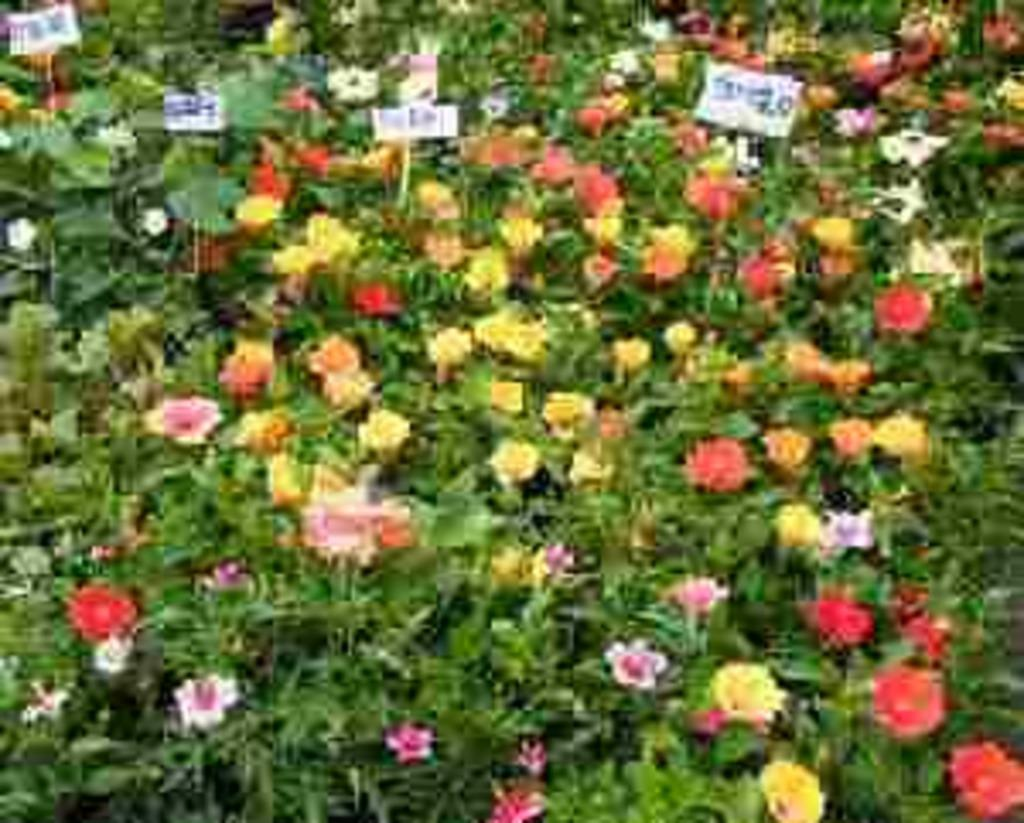What type of landscape is depicted in the image? There is a flower garden in the image. Can you describe the flowers in the garden? The flowers in the garden have different colors. What type of treatment is being administered to the butter in the image? There is no butter present in the image; it is a flower garden with flowers of different colors. 